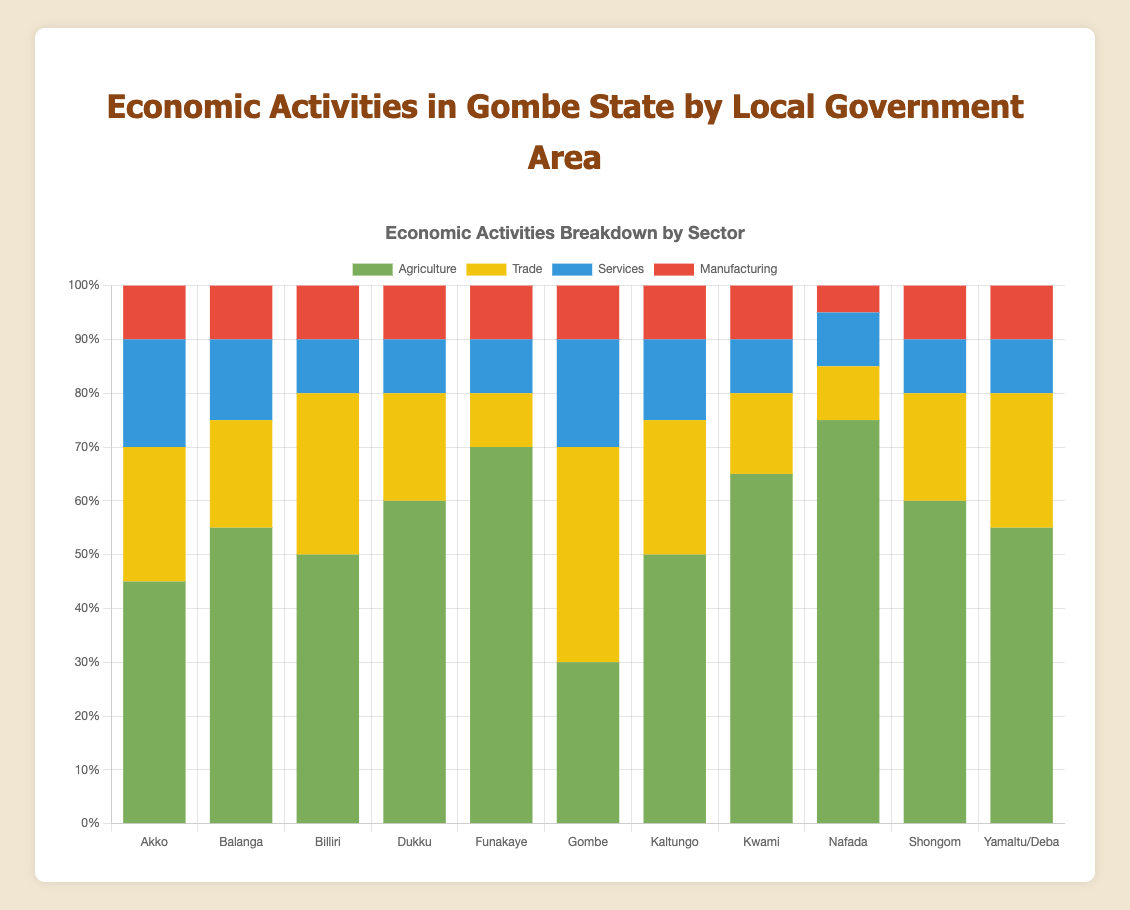Which Local Government Area has the highest percentage in Agriculture? By observing the green segments in the chart, we see that Nafada has the tallest green bar representing 75% Agriculture.
Answer: Nafada Which Local Government Area has the lowest contribution from Manufacturing? Compare the red segments across all areas. Nafada has the smallest red segment at 5%.
Answer: Nafada Summing up the percentage of Agriculture and Trade in Gombe, what is the total? Agriculture (30%) + Trade (40%) = 70%
Answer: 70% Which Local Government Area has an equal percentage of Services and Manufacturing? Look for areas where blue and red segments are of equal height. Akko, Dukku, and Yamaltu/Deba all have 10% each in Services and Manufacturing.
Answer: Akko, Dukku, Yamaltu/Deba Compare the total percentage of non-agricultural sectors (Trade, Services, and Manufacturing) in Kwami and Gombe; which is higher? In Kwami, non-agriculture sums to 15 + 10 + 10 = 35%. In Gombe, it's 40 + 20 + 10 = 70%. Gombe's total is higher.
Answer: Gombe How does the percentage of Agriculture in Funakaye compare to that in Gombe? Funakaye has 70% Agriculture compared to Gombe's 30%, making it more than double.
Answer: More than double Which Local Government Area has the least combined percentage in Trade and Services? Calculate the sum of Trade and Services for each LGA. Funakaye and Nafada both sum to 20% (10% + 10%).
Answer: Funakaye, Nafada Looking at the bars, which Local Government Area has the tallest blue segment? Identify the tallest blue bar visually, which belongs to Gombe with 20% in Services.
Answer: Gombe Comparing Akko and Kaltungo, which one has a higher percentage of their economy in Trade? Akko has 25% in Trade while Kaltungo has 25%. Both are equal.
Answer: Equal 